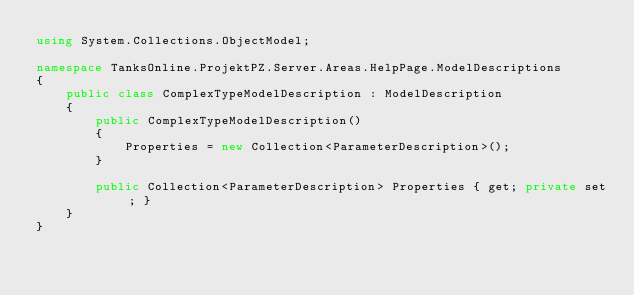<code> <loc_0><loc_0><loc_500><loc_500><_C#_>using System.Collections.ObjectModel;

namespace TanksOnline.ProjektPZ.Server.Areas.HelpPage.ModelDescriptions
{
    public class ComplexTypeModelDescription : ModelDescription
    {
        public ComplexTypeModelDescription()
        {
            Properties = new Collection<ParameterDescription>();
        }

        public Collection<ParameterDescription> Properties { get; private set; }
    }
}</code> 